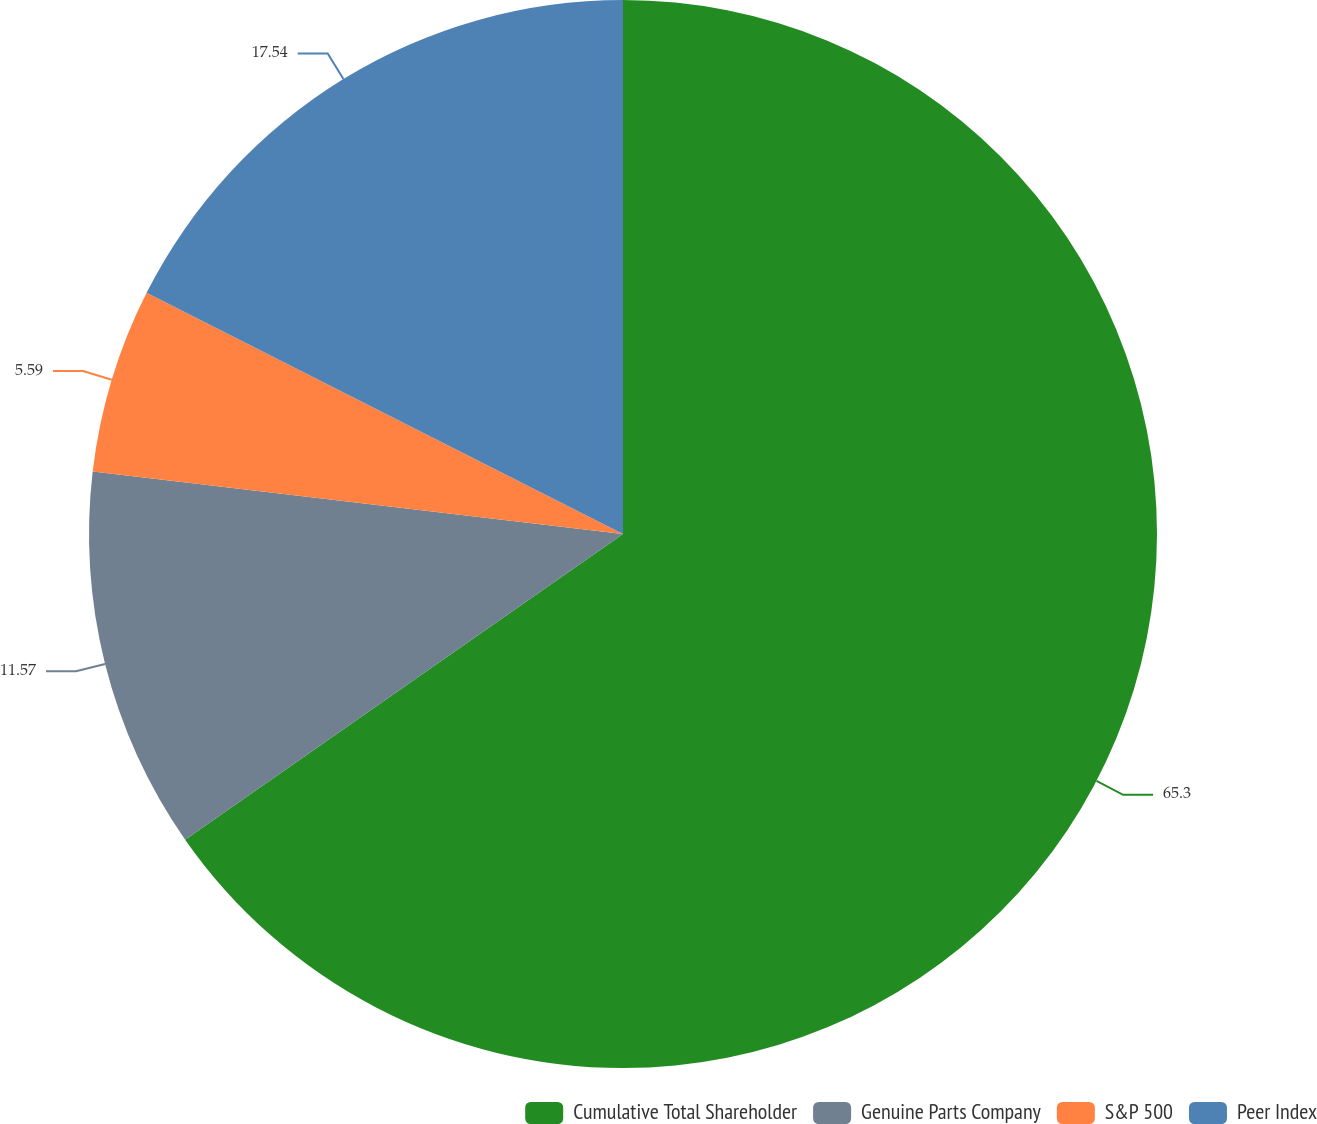Convert chart to OTSL. <chart><loc_0><loc_0><loc_500><loc_500><pie_chart><fcel>Cumulative Total Shareholder<fcel>Genuine Parts Company<fcel>S&P 500<fcel>Peer Index<nl><fcel>65.3%<fcel>11.57%<fcel>5.59%<fcel>17.54%<nl></chart> 